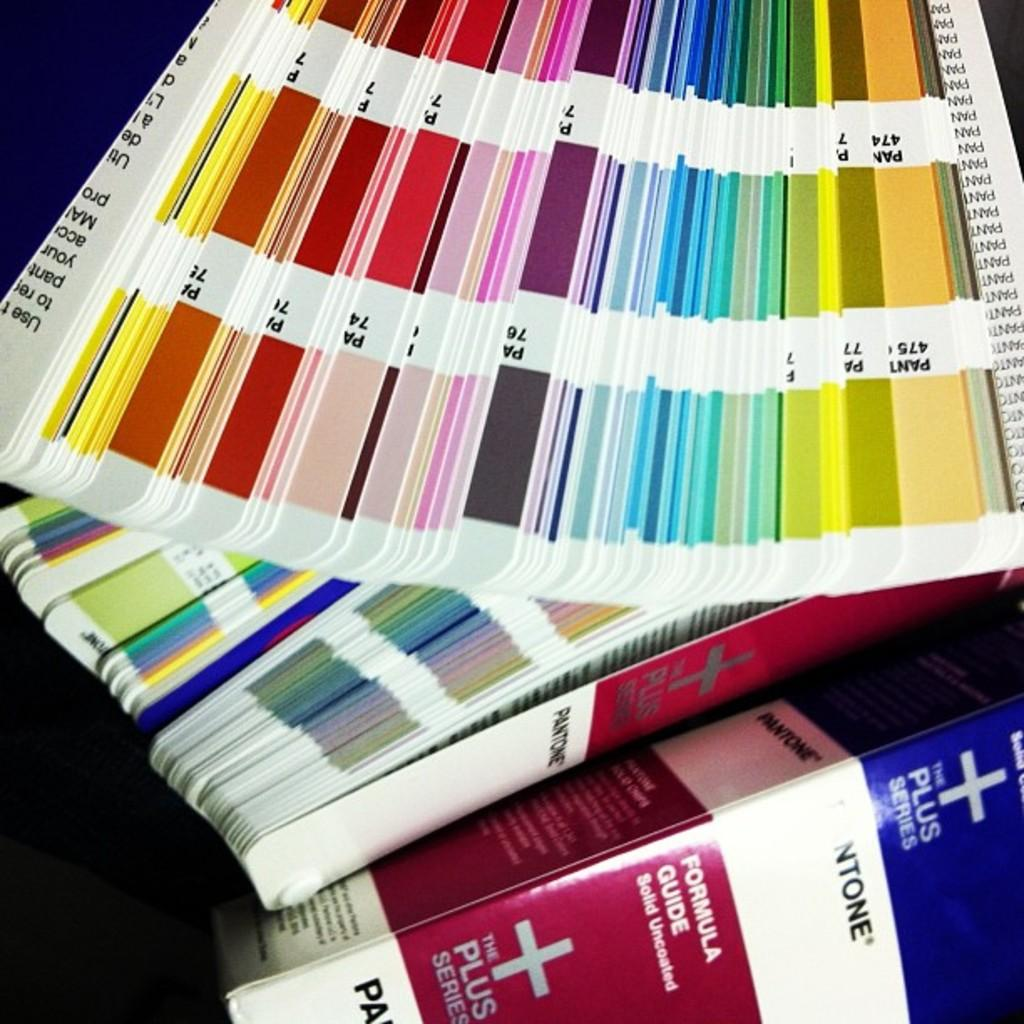<image>
Present a compact description of the photo's key features. a paper color wheel of swatched ntone solid uncoated paints 